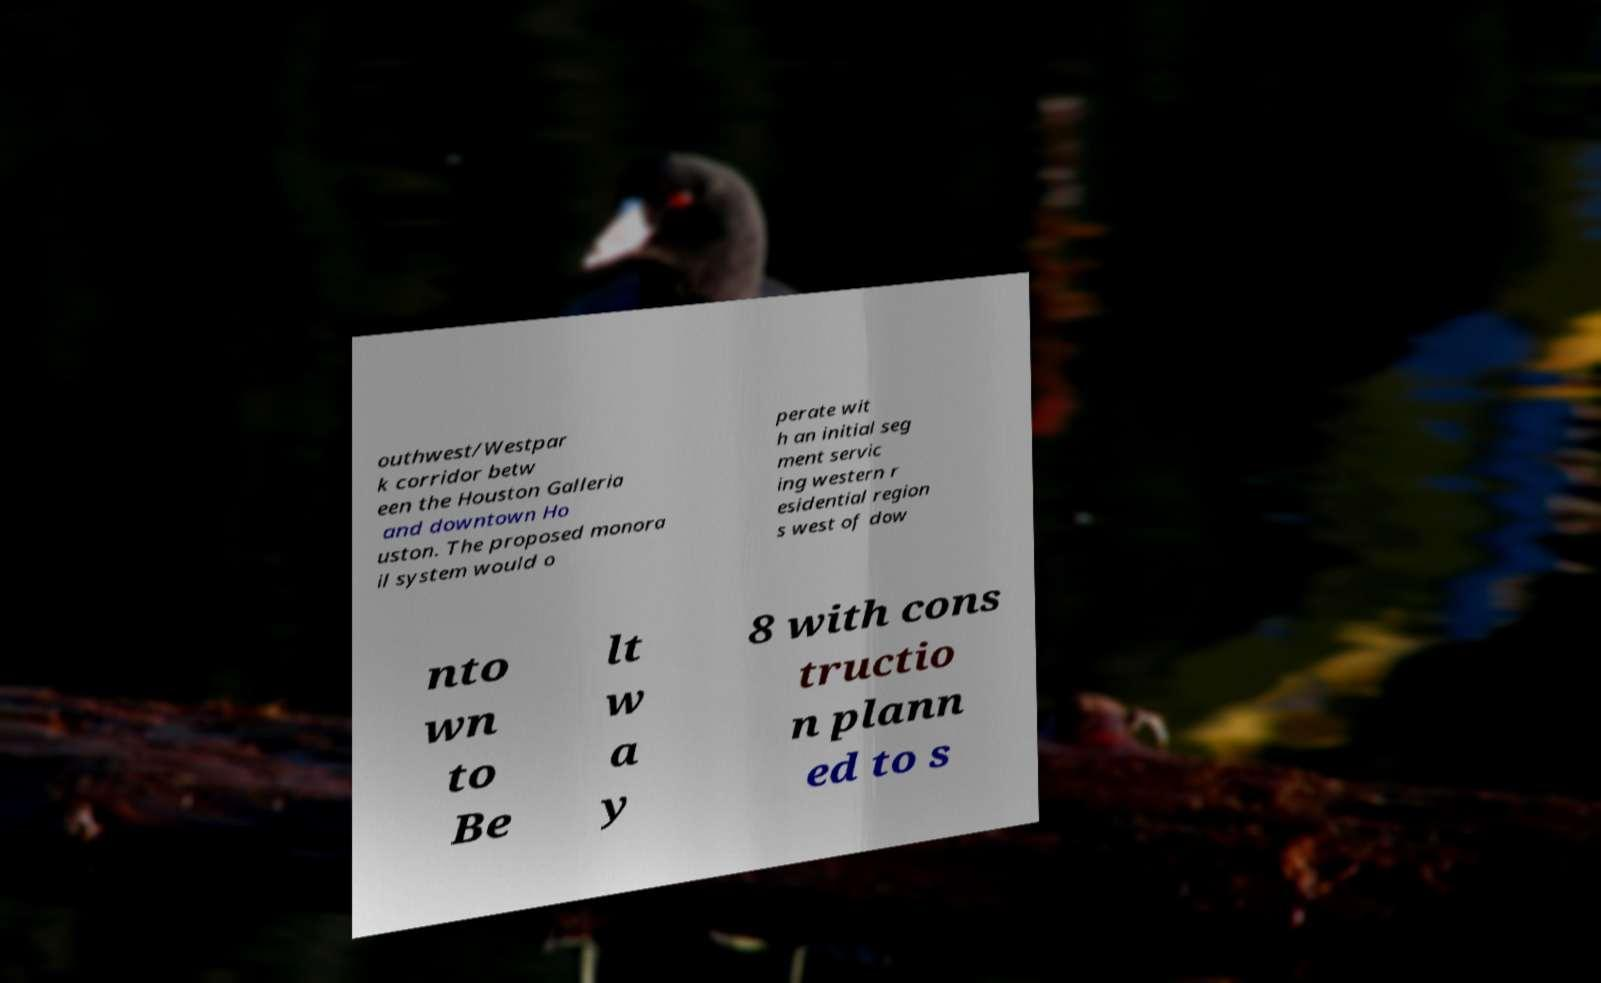I need the written content from this picture converted into text. Can you do that? outhwest/Westpar k corridor betw een the Houston Galleria and downtown Ho uston. The proposed monora il system would o perate wit h an initial seg ment servic ing western r esidential region s west of dow nto wn to Be lt w a y 8 with cons tructio n plann ed to s 